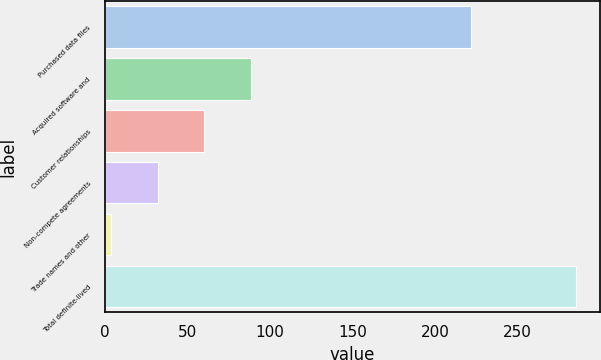<chart> <loc_0><loc_0><loc_500><loc_500><bar_chart><fcel>Purchased data files<fcel>Acquired software and<fcel>Customer relationships<fcel>Non-compete agreements<fcel>Trade names and other<fcel>Total definite-lived<nl><fcel>221.7<fcel>88.35<fcel>60.2<fcel>32.05<fcel>3.9<fcel>285.4<nl></chart> 